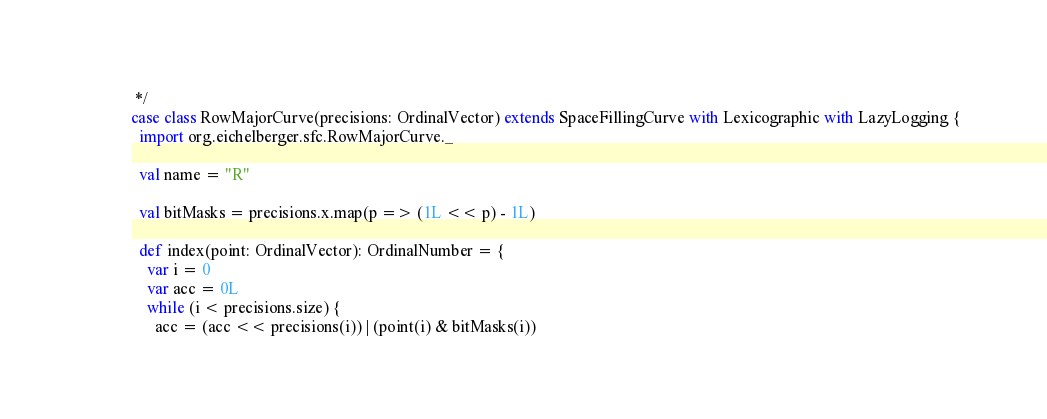Convert code to text. <code><loc_0><loc_0><loc_500><loc_500><_Scala_> */
case class RowMajorCurve(precisions: OrdinalVector) extends SpaceFillingCurve with Lexicographic with LazyLogging {
  import org.eichelberger.sfc.RowMajorCurve._

  val name = "R"

  val bitMasks = precisions.x.map(p => (1L << p) - 1L)

  def index(point: OrdinalVector): OrdinalNumber = {
    var i = 0
    var acc = 0L
    while (i < precisions.size) {
      acc = (acc << precisions(i)) | (point(i) & bitMasks(i))</code> 